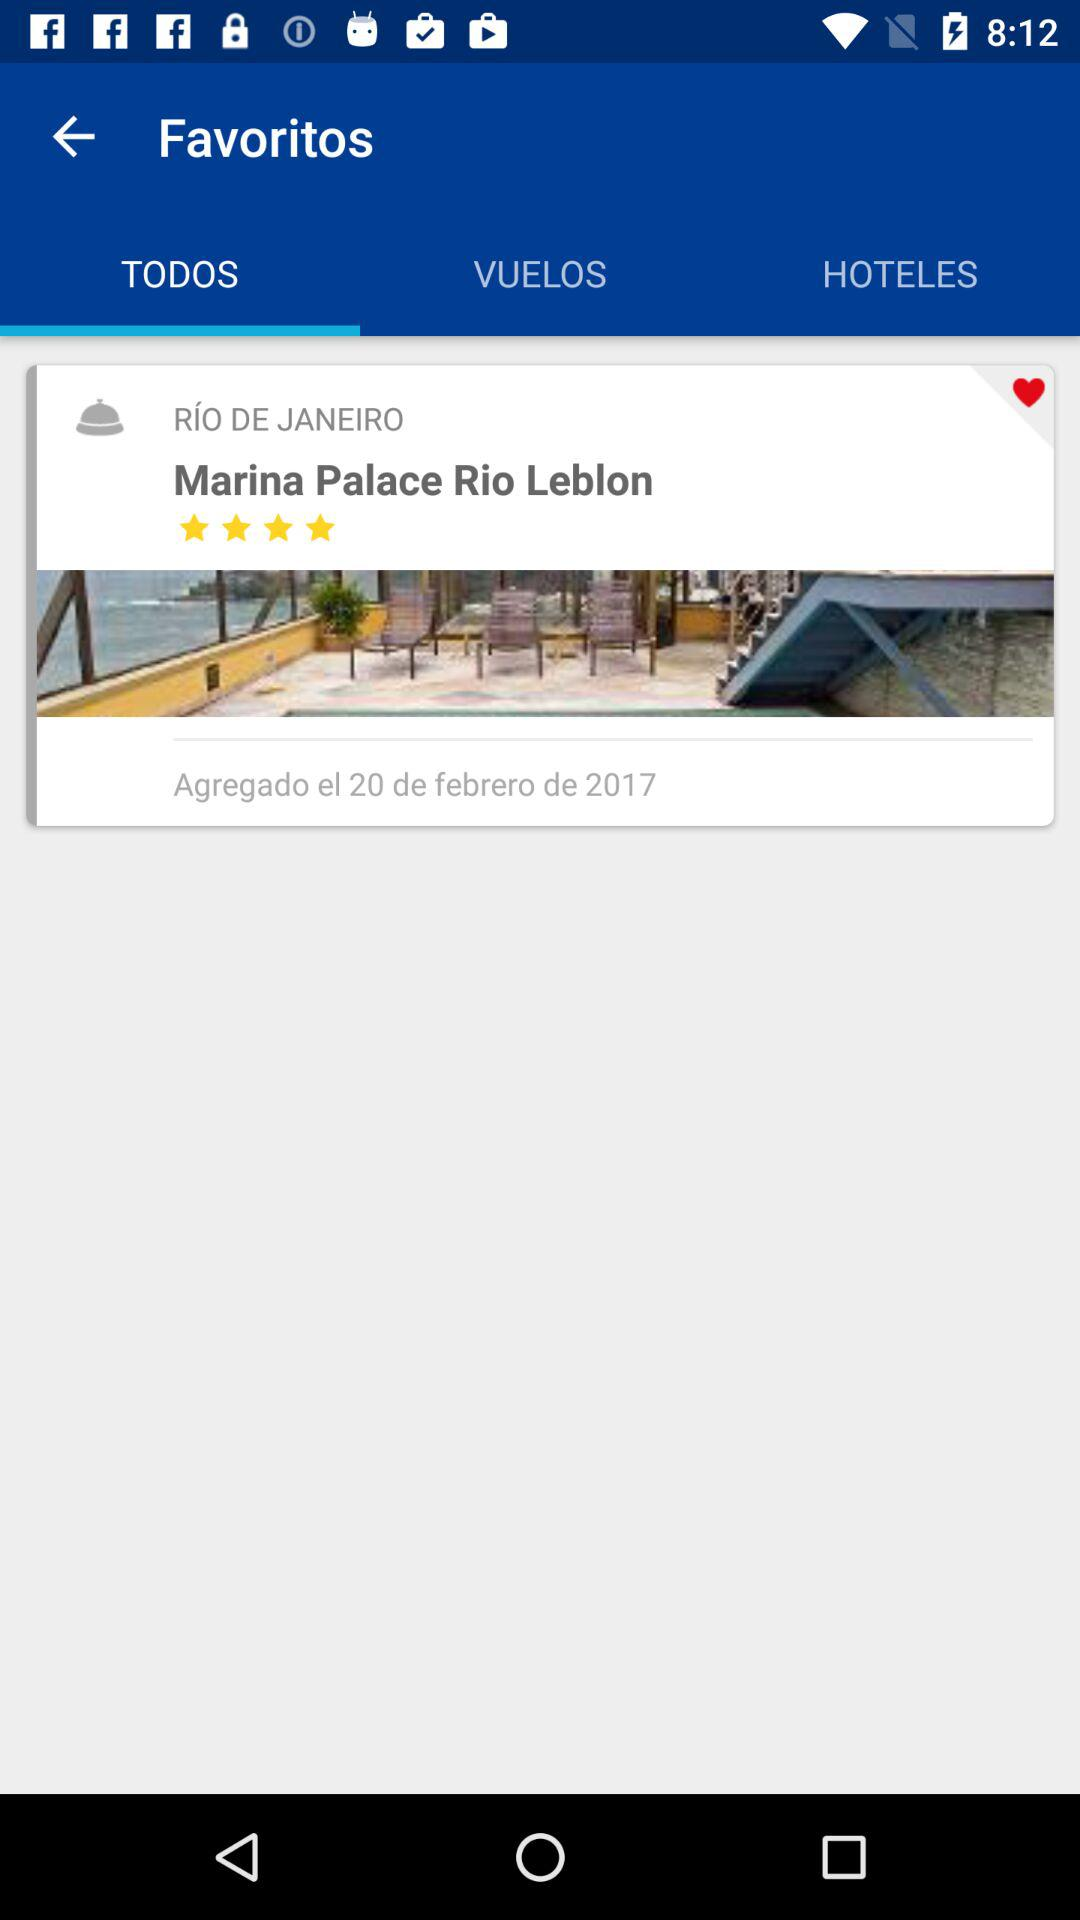What is the name of the hotel? The name of the hotel is "Marina Palace Rio Leblon". 